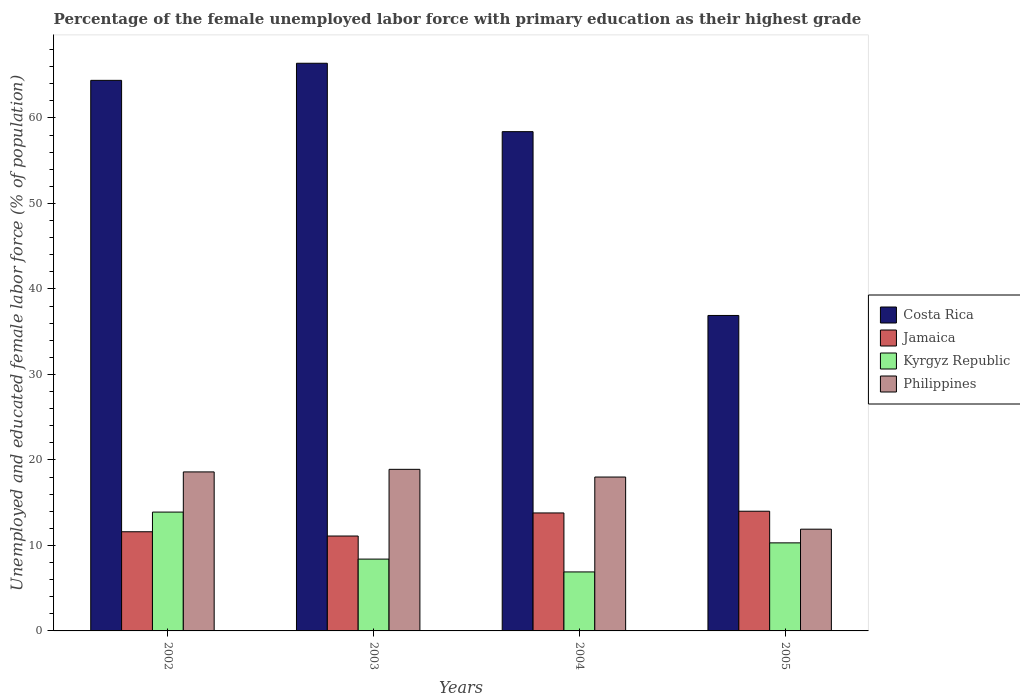How many different coloured bars are there?
Your answer should be very brief. 4. How many groups of bars are there?
Your answer should be very brief. 4. Are the number of bars on each tick of the X-axis equal?
Offer a very short reply. Yes. How many bars are there on the 1st tick from the right?
Offer a terse response. 4. What is the label of the 4th group of bars from the left?
Your answer should be compact. 2005. In how many cases, is the number of bars for a given year not equal to the number of legend labels?
Ensure brevity in your answer.  0. What is the percentage of the unemployed female labor force with primary education in Jamaica in 2002?
Give a very brief answer. 11.6. Across all years, what is the maximum percentage of the unemployed female labor force with primary education in Philippines?
Keep it short and to the point. 18.9. Across all years, what is the minimum percentage of the unemployed female labor force with primary education in Jamaica?
Give a very brief answer. 11.1. In which year was the percentage of the unemployed female labor force with primary education in Kyrgyz Republic maximum?
Your response must be concise. 2002. What is the total percentage of the unemployed female labor force with primary education in Jamaica in the graph?
Offer a terse response. 50.5. What is the difference between the percentage of the unemployed female labor force with primary education in Jamaica in 2003 and that in 2005?
Offer a terse response. -2.9. What is the difference between the percentage of the unemployed female labor force with primary education in Costa Rica in 2005 and the percentage of the unemployed female labor force with primary education in Philippines in 2004?
Offer a very short reply. 18.9. What is the average percentage of the unemployed female labor force with primary education in Jamaica per year?
Your response must be concise. 12.63. In the year 2004, what is the difference between the percentage of the unemployed female labor force with primary education in Jamaica and percentage of the unemployed female labor force with primary education in Kyrgyz Republic?
Give a very brief answer. 6.9. What is the ratio of the percentage of the unemployed female labor force with primary education in Kyrgyz Republic in 2002 to that in 2005?
Your answer should be compact. 1.35. Is the percentage of the unemployed female labor force with primary education in Costa Rica in 2003 less than that in 2005?
Provide a short and direct response. No. What is the difference between the highest and the second highest percentage of the unemployed female labor force with primary education in Philippines?
Your answer should be very brief. 0.3. What is the difference between the highest and the lowest percentage of the unemployed female labor force with primary education in Costa Rica?
Your response must be concise. 29.5. In how many years, is the percentage of the unemployed female labor force with primary education in Kyrgyz Republic greater than the average percentage of the unemployed female labor force with primary education in Kyrgyz Republic taken over all years?
Your response must be concise. 2. Is the sum of the percentage of the unemployed female labor force with primary education in Costa Rica in 2002 and 2004 greater than the maximum percentage of the unemployed female labor force with primary education in Jamaica across all years?
Give a very brief answer. Yes. Is it the case that in every year, the sum of the percentage of the unemployed female labor force with primary education in Costa Rica and percentage of the unemployed female labor force with primary education in Philippines is greater than the sum of percentage of the unemployed female labor force with primary education in Kyrgyz Republic and percentage of the unemployed female labor force with primary education in Jamaica?
Keep it short and to the point. Yes. What does the 3rd bar from the left in 2004 represents?
Your response must be concise. Kyrgyz Republic. What does the 2nd bar from the right in 2004 represents?
Your answer should be compact. Kyrgyz Republic. How many years are there in the graph?
Offer a very short reply. 4. What is the difference between two consecutive major ticks on the Y-axis?
Your response must be concise. 10. How are the legend labels stacked?
Make the answer very short. Vertical. What is the title of the graph?
Provide a succinct answer. Percentage of the female unemployed labor force with primary education as their highest grade. What is the label or title of the Y-axis?
Ensure brevity in your answer.  Unemployed and educated female labor force (% of population). What is the Unemployed and educated female labor force (% of population) of Costa Rica in 2002?
Your response must be concise. 64.4. What is the Unemployed and educated female labor force (% of population) in Jamaica in 2002?
Provide a short and direct response. 11.6. What is the Unemployed and educated female labor force (% of population) of Kyrgyz Republic in 2002?
Your response must be concise. 13.9. What is the Unemployed and educated female labor force (% of population) of Philippines in 2002?
Keep it short and to the point. 18.6. What is the Unemployed and educated female labor force (% of population) in Costa Rica in 2003?
Provide a short and direct response. 66.4. What is the Unemployed and educated female labor force (% of population) in Jamaica in 2003?
Give a very brief answer. 11.1. What is the Unemployed and educated female labor force (% of population) in Kyrgyz Republic in 2003?
Offer a very short reply. 8.4. What is the Unemployed and educated female labor force (% of population) of Philippines in 2003?
Offer a terse response. 18.9. What is the Unemployed and educated female labor force (% of population) in Costa Rica in 2004?
Your response must be concise. 58.4. What is the Unemployed and educated female labor force (% of population) of Jamaica in 2004?
Provide a short and direct response. 13.8. What is the Unemployed and educated female labor force (% of population) of Kyrgyz Republic in 2004?
Give a very brief answer. 6.9. What is the Unemployed and educated female labor force (% of population) in Costa Rica in 2005?
Give a very brief answer. 36.9. What is the Unemployed and educated female labor force (% of population) in Kyrgyz Republic in 2005?
Provide a short and direct response. 10.3. What is the Unemployed and educated female labor force (% of population) of Philippines in 2005?
Provide a short and direct response. 11.9. Across all years, what is the maximum Unemployed and educated female labor force (% of population) in Costa Rica?
Offer a very short reply. 66.4. Across all years, what is the maximum Unemployed and educated female labor force (% of population) in Kyrgyz Republic?
Offer a very short reply. 13.9. Across all years, what is the maximum Unemployed and educated female labor force (% of population) of Philippines?
Offer a very short reply. 18.9. Across all years, what is the minimum Unemployed and educated female labor force (% of population) of Costa Rica?
Provide a short and direct response. 36.9. Across all years, what is the minimum Unemployed and educated female labor force (% of population) of Jamaica?
Keep it short and to the point. 11.1. Across all years, what is the minimum Unemployed and educated female labor force (% of population) in Kyrgyz Republic?
Offer a very short reply. 6.9. Across all years, what is the minimum Unemployed and educated female labor force (% of population) in Philippines?
Offer a very short reply. 11.9. What is the total Unemployed and educated female labor force (% of population) in Costa Rica in the graph?
Your answer should be compact. 226.1. What is the total Unemployed and educated female labor force (% of population) of Jamaica in the graph?
Offer a terse response. 50.5. What is the total Unemployed and educated female labor force (% of population) of Kyrgyz Republic in the graph?
Make the answer very short. 39.5. What is the total Unemployed and educated female labor force (% of population) of Philippines in the graph?
Make the answer very short. 67.4. What is the difference between the Unemployed and educated female labor force (% of population) of Jamaica in 2002 and that in 2003?
Make the answer very short. 0.5. What is the difference between the Unemployed and educated female labor force (% of population) in Kyrgyz Republic in 2002 and that in 2003?
Offer a terse response. 5.5. What is the difference between the Unemployed and educated female labor force (% of population) of Kyrgyz Republic in 2002 and that in 2004?
Offer a very short reply. 7. What is the difference between the Unemployed and educated female labor force (% of population) in Philippines in 2002 and that in 2004?
Make the answer very short. 0.6. What is the difference between the Unemployed and educated female labor force (% of population) of Costa Rica in 2002 and that in 2005?
Offer a very short reply. 27.5. What is the difference between the Unemployed and educated female labor force (% of population) of Kyrgyz Republic in 2002 and that in 2005?
Make the answer very short. 3.6. What is the difference between the Unemployed and educated female labor force (% of population) of Costa Rica in 2003 and that in 2004?
Ensure brevity in your answer.  8. What is the difference between the Unemployed and educated female labor force (% of population) in Kyrgyz Republic in 2003 and that in 2004?
Your answer should be very brief. 1.5. What is the difference between the Unemployed and educated female labor force (% of population) of Philippines in 2003 and that in 2004?
Offer a very short reply. 0.9. What is the difference between the Unemployed and educated female labor force (% of population) of Costa Rica in 2003 and that in 2005?
Your response must be concise. 29.5. What is the difference between the Unemployed and educated female labor force (% of population) in Kyrgyz Republic in 2003 and that in 2005?
Provide a short and direct response. -1.9. What is the difference between the Unemployed and educated female labor force (% of population) in Philippines in 2003 and that in 2005?
Give a very brief answer. 7. What is the difference between the Unemployed and educated female labor force (% of population) in Costa Rica in 2004 and that in 2005?
Offer a very short reply. 21.5. What is the difference between the Unemployed and educated female labor force (% of population) of Costa Rica in 2002 and the Unemployed and educated female labor force (% of population) of Jamaica in 2003?
Your answer should be very brief. 53.3. What is the difference between the Unemployed and educated female labor force (% of population) of Costa Rica in 2002 and the Unemployed and educated female labor force (% of population) of Kyrgyz Republic in 2003?
Your answer should be compact. 56. What is the difference between the Unemployed and educated female labor force (% of population) of Costa Rica in 2002 and the Unemployed and educated female labor force (% of population) of Philippines in 2003?
Offer a terse response. 45.5. What is the difference between the Unemployed and educated female labor force (% of population) of Jamaica in 2002 and the Unemployed and educated female labor force (% of population) of Philippines in 2003?
Make the answer very short. -7.3. What is the difference between the Unemployed and educated female labor force (% of population) of Kyrgyz Republic in 2002 and the Unemployed and educated female labor force (% of population) of Philippines in 2003?
Your answer should be compact. -5. What is the difference between the Unemployed and educated female labor force (% of population) in Costa Rica in 2002 and the Unemployed and educated female labor force (% of population) in Jamaica in 2004?
Offer a very short reply. 50.6. What is the difference between the Unemployed and educated female labor force (% of population) in Costa Rica in 2002 and the Unemployed and educated female labor force (% of population) in Kyrgyz Republic in 2004?
Offer a terse response. 57.5. What is the difference between the Unemployed and educated female labor force (% of population) in Costa Rica in 2002 and the Unemployed and educated female labor force (% of population) in Philippines in 2004?
Ensure brevity in your answer.  46.4. What is the difference between the Unemployed and educated female labor force (% of population) in Jamaica in 2002 and the Unemployed and educated female labor force (% of population) in Kyrgyz Republic in 2004?
Offer a terse response. 4.7. What is the difference between the Unemployed and educated female labor force (% of population) of Jamaica in 2002 and the Unemployed and educated female labor force (% of population) of Philippines in 2004?
Keep it short and to the point. -6.4. What is the difference between the Unemployed and educated female labor force (% of population) in Kyrgyz Republic in 2002 and the Unemployed and educated female labor force (% of population) in Philippines in 2004?
Make the answer very short. -4.1. What is the difference between the Unemployed and educated female labor force (% of population) in Costa Rica in 2002 and the Unemployed and educated female labor force (% of population) in Jamaica in 2005?
Provide a short and direct response. 50.4. What is the difference between the Unemployed and educated female labor force (% of population) in Costa Rica in 2002 and the Unemployed and educated female labor force (% of population) in Kyrgyz Republic in 2005?
Provide a succinct answer. 54.1. What is the difference between the Unemployed and educated female labor force (% of population) of Costa Rica in 2002 and the Unemployed and educated female labor force (% of population) of Philippines in 2005?
Offer a very short reply. 52.5. What is the difference between the Unemployed and educated female labor force (% of population) of Jamaica in 2002 and the Unemployed and educated female labor force (% of population) of Philippines in 2005?
Offer a very short reply. -0.3. What is the difference between the Unemployed and educated female labor force (% of population) of Costa Rica in 2003 and the Unemployed and educated female labor force (% of population) of Jamaica in 2004?
Provide a short and direct response. 52.6. What is the difference between the Unemployed and educated female labor force (% of population) in Costa Rica in 2003 and the Unemployed and educated female labor force (% of population) in Kyrgyz Republic in 2004?
Your answer should be compact. 59.5. What is the difference between the Unemployed and educated female labor force (% of population) of Costa Rica in 2003 and the Unemployed and educated female labor force (% of population) of Philippines in 2004?
Keep it short and to the point. 48.4. What is the difference between the Unemployed and educated female labor force (% of population) of Jamaica in 2003 and the Unemployed and educated female labor force (% of population) of Philippines in 2004?
Keep it short and to the point. -6.9. What is the difference between the Unemployed and educated female labor force (% of population) in Costa Rica in 2003 and the Unemployed and educated female labor force (% of population) in Jamaica in 2005?
Offer a terse response. 52.4. What is the difference between the Unemployed and educated female labor force (% of population) in Costa Rica in 2003 and the Unemployed and educated female labor force (% of population) in Kyrgyz Republic in 2005?
Offer a terse response. 56.1. What is the difference between the Unemployed and educated female labor force (% of population) of Costa Rica in 2003 and the Unemployed and educated female labor force (% of population) of Philippines in 2005?
Offer a very short reply. 54.5. What is the difference between the Unemployed and educated female labor force (% of population) in Jamaica in 2003 and the Unemployed and educated female labor force (% of population) in Philippines in 2005?
Provide a succinct answer. -0.8. What is the difference between the Unemployed and educated female labor force (% of population) of Costa Rica in 2004 and the Unemployed and educated female labor force (% of population) of Jamaica in 2005?
Your answer should be very brief. 44.4. What is the difference between the Unemployed and educated female labor force (% of population) of Costa Rica in 2004 and the Unemployed and educated female labor force (% of population) of Kyrgyz Republic in 2005?
Provide a short and direct response. 48.1. What is the difference between the Unemployed and educated female labor force (% of population) in Costa Rica in 2004 and the Unemployed and educated female labor force (% of population) in Philippines in 2005?
Provide a short and direct response. 46.5. What is the difference between the Unemployed and educated female labor force (% of population) of Jamaica in 2004 and the Unemployed and educated female labor force (% of population) of Philippines in 2005?
Your answer should be very brief. 1.9. What is the difference between the Unemployed and educated female labor force (% of population) in Kyrgyz Republic in 2004 and the Unemployed and educated female labor force (% of population) in Philippines in 2005?
Make the answer very short. -5. What is the average Unemployed and educated female labor force (% of population) in Costa Rica per year?
Offer a very short reply. 56.52. What is the average Unemployed and educated female labor force (% of population) of Jamaica per year?
Your answer should be very brief. 12.62. What is the average Unemployed and educated female labor force (% of population) in Kyrgyz Republic per year?
Offer a very short reply. 9.88. What is the average Unemployed and educated female labor force (% of population) in Philippines per year?
Give a very brief answer. 16.85. In the year 2002, what is the difference between the Unemployed and educated female labor force (% of population) of Costa Rica and Unemployed and educated female labor force (% of population) of Jamaica?
Keep it short and to the point. 52.8. In the year 2002, what is the difference between the Unemployed and educated female labor force (% of population) of Costa Rica and Unemployed and educated female labor force (% of population) of Kyrgyz Republic?
Your answer should be compact. 50.5. In the year 2002, what is the difference between the Unemployed and educated female labor force (% of population) of Costa Rica and Unemployed and educated female labor force (% of population) of Philippines?
Provide a short and direct response. 45.8. In the year 2002, what is the difference between the Unemployed and educated female labor force (% of population) of Jamaica and Unemployed and educated female labor force (% of population) of Kyrgyz Republic?
Keep it short and to the point. -2.3. In the year 2002, what is the difference between the Unemployed and educated female labor force (% of population) of Jamaica and Unemployed and educated female labor force (% of population) of Philippines?
Your answer should be compact. -7. In the year 2002, what is the difference between the Unemployed and educated female labor force (% of population) of Kyrgyz Republic and Unemployed and educated female labor force (% of population) of Philippines?
Ensure brevity in your answer.  -4.7. In the year 2003, what is the difference between the Unemployed and educated female labor force (% of population) in Costa Rica and Unemployed and educated female labor force (% of population) in Jamaica?
Keep it short and to the point. 55.3. In the year 2003, what is the difference between the Unemployed and educated female labor force (% of population) of Costa Rica and Unemployed and educated female labor force (% of population) of Philippines?
Offer a terse response. 47.5. In the year 2004, what is the difference between the Unemployed and educated female labor force (% of population) in Costa Rica and Unemployed and educated female labor force (% of population) in Jamaica?
Make the answer very short. 44.6. In the year 2004, what is the difference between the Unemployed and educated female labor force (% of population) of Costa Rica and Unemployed and educated female labor force (% of population) of Kyrgyz Republic?
Keep it short and to the point. 51.5. In the year 2004, what is the difference between the Unemployed and educated female labor force (% of population) of Costa Rica and Unemployed and educated female labor force (% of population) of Philippines?
Your answer should be very brief. 40.4. In the year 2004, what is the difference between the Unemployed and educated female labor force (% of population) of Kyrgyz Republic and Unemployed and educated female labor force (% of population) of Philippines?
Ensure brevity in your answer.  -11.1. In the year 2005, what is the difference between the Unemployed and educated female labor force (% of population) in Costa Rica and Unemployed and educated female labor force (% of population) in Jamaica?
Ensure brevity in your answer.  22.9. In the year 2005, what is the difference between the Unemployed and educated female labor force (% of population) in Costa Rica and Unemployed and educated female labor force (% of population) in Kyrgyz Republic?
Your answer should be compact. 26.6. In the year 2005, what is the difference between the Unemployed and educated female labor force (% of population) of Costa Rica and Unemployed and educated female labor force (% of population) of Philippines?
Offer a very short reply. 25. In the year 2005, what is the difference between the Unemployed and educated female labor force (% of population) of Jamaica and Unemployed and educated female labor force (% of population) of Philippines?
Offer a terse response. 2.1. What is the ratio of the Unemployed and educated female labor force (% of population) of Costa Rica in 2002 to that in 2003?
Provide a short and direct response. 0.97. What is the ratio of the Unemployed and educated female labor force (% of population) in Jamaica in 2002 to that in 2003?
Provide a succinct answer. 1.04. What is the ratio of the Unemployed and educated female labor force (% of population) of Kyrgyz Republic in 2002 to that in 2003?
Offer a very short reply. 1.65. What is the ratio of the Unemployed and educated female labor force (% of population) of Philippines in 2002 to that in 2003?
Offer a terse response. 0.98. What is the ratio of the Unemployed and educated female labor force (% of population) of Costa Rica in 2002 to that in 2004?
Your response must be concise. 1.1. What is the ratio of the Unemployed and educated female labor force (% of population) in Jamaica in 2002 to that in 2004?
Offer a terse response. 0.84. What is the ratio of the Unemployed and educated female labor force (% of population) of Kyrgyz Republic in 2002 to that in 2004?
Ensure brevity in your answer.  2.01. What is the ratio of the Unemployed and educated female labor force (% of population) of Costa Rica in 2002 to that in 2005?
Your answer should be very brief. 1.75. What is the ratio of the Unemployed and educated female labor force (% of population) of Jamaica in 2002 to that in 2005?
Ensure brevity in your answer.  0.83. What is the ratio of the Unemployed and educated female labor force (% of population) of Kyrgyz Republic in 2002 to that in 2005?
Offer a very short reply. 1.35. What is the ratio of the Unemployed and educated female labor force (% of population) of Philippines in 2002 to that in 2005?
Your answer should be very brief. 1.56. What is the ratio of the Unemployed and educated female labor force (% of population) in Costa Rica in 2003 to that in 2004?
Offer a terse response. 1.14. What is the ratio of the Unemployed and educated female labor force (% of population) of Jamaica in 2003 to that in 2004?
Provide a succinct answer. 0.8. What is the ratio of the Unemployed and educated female labor force (% of population) in Kyrgyz Republic in 2003 to that in 2004?
Your answer should be very brief. 1.22. What is the ratio of the Unemployed and educated female labor force (% of population) of Costa Rica in 2003 to that in 2005?
Keep it short and to the point. 1.8. What is the ratio of the Unemployed and educated female labor force (% of population) of Jamaica in 2003 to that in 2005?
Your answer should be compact. 0.79. What is the ratio of the Unemployed and educated female labor force (% of population) in Kyrgyz Republic in 2003 to that in 2005?
Your answer should be compact. 0.82. What is the ratio of the Unemployed and educated female labor force (% of population) of Philippines in 2003 to that in 2005?
Provide a succinct answer. 1.59. What is the ratio of the Unemployed and educated female labor force (% of population) in Costa Rica in 2004 to that in 2005?
Your answer should be very brief. 1.58. What is the ratio of the Unemployed and educated female labor force (% of population) of Jamaica in 2004 to that in 2005?
Give a very brief answer. 0.99. What is the ratio of the Unemployed and educated female labor force (% of population) in Kyrgyz Republic in 2004 to that in 2005?
Ensure brevity in your answer.  0.67. What is the ratio of the Unemployed and educated female labor force (% of population) in Philippines in 2004 to that in 2005?
Provide a succinct answer. 1.51. What is the difference between the highest and the second highest Unemployed and educated female labor force (% of population) of Costa Rica?
Offer a very short reply. 2. What is the difference between the highest and the second highest Unemployed and educated female labor force (% of population) of Jamaica?
Offer a very short reply. 0.2. What is the difference between the highest and the second highest Unemployed and educated female labor force (% of population) in Kyrgyz Republic?
Provide a succinct answer. 3.6. What is the difference between the highest and the lowest Unemployed and educated female labor force (% of population) in Costa Rica?
Keep it short and to the point. 29.5. What is the difference between the highest and the lowest Unemployed and educated female labor force (% of population) of Jamaica?
Your answer should be very brief. 2.9. 